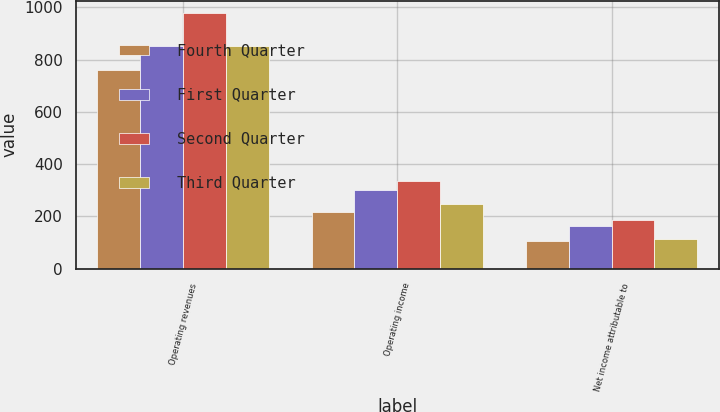<chart> <loc_0><loc_0><loc_500><loc_500><stacked_bar_chart><ecel><fcel>Operating revenues<fcel>Operating income<fcel>Net income attributable to<nl><fcel>Fourth Quarter<fcel>761<fcel>217<fcel>106<nl><fcel>First Quarter<fcel>853<fcel>302<fcel>162<nl><fcel>Second Quarter<fcel>976<fcel>335<fcel>187<nl><fcel>Third Quarter<fcel>850<fcel>248<fcel>112<nl></chart> 